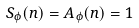Convert formula to latex. <formula><loc_0><loc_0><loc_500><loc_500>S _ { \phi } ( n ) = A _ { \phi } ( n ) = 1</formula> 